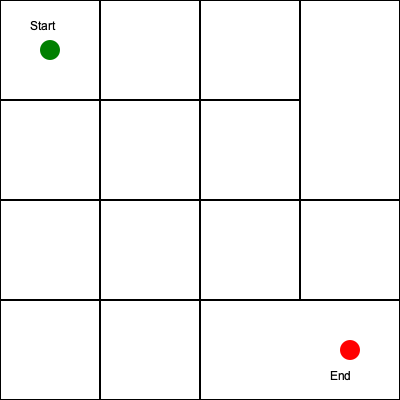As a coordinator for volunteer educational workshops, you need to guide new volunteers through the hospital efficiently. Given the hospital floor plan maze above, what is the minimum number of grid squares that must be traversed to reach the end point (red circle) from the start point (green circle)? To find the shortest path through the hospital floor plan maze, we need to follow these steps:

1. Identify the start point (green circle) and end point (red circle).
2. Count the grid squares horizontally and vertically between the start and end points.
3. The shortest path will always be the sum of horizontal and vertical movements, as diagonal movements are not allowed in this grid-based maze.

Step-by-step counting:

1. Horizontal movement:
   - Start point is in the leftmost column
   - End point is in the rightmost column
   - Total horizontal squares to traverse: 3

2. Vertical movement:
   - Start point is in the top row
   - End point is in the bottom row
   - Total vertical squares to traverse: 3

3. Calculate the total number of squares:
   $$ \text{Total squares} = \text{Horizontal squares} + \text{Vertical squares} $$
   $$ \text{Total squares} = 3 + 3 = 6 $$

Therefore, the minimum number of grid squares that must be traversed is 6.
Answer: 6 